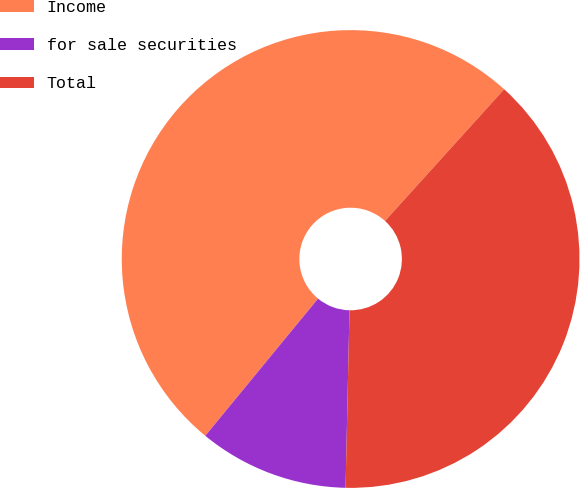<chart> <loc_0><loc_0><loc_500><loc_500><pie_chart><fcel>Income<fcel>for sale securities<fcel>Total<nl><fcel>50.75%<fcel>10.6%<fcel>38.65%<nl></chart> 